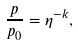Convert formula to latex. <formula><loc_0><loc_0><loc_500><loc_500>\frac { p } { p _ { 0 } } = \eta ^ { - k } ,</formula> 